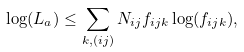Convert formula to latex. <formula><loc_0><loc_0><loc_500><loc_500>\log ( L _ { a } ) \leq \sum _ { k , ( i j ) } N _ { i j } f _ { i j k } \log ( f _ { i j k } ) ,</formula> 